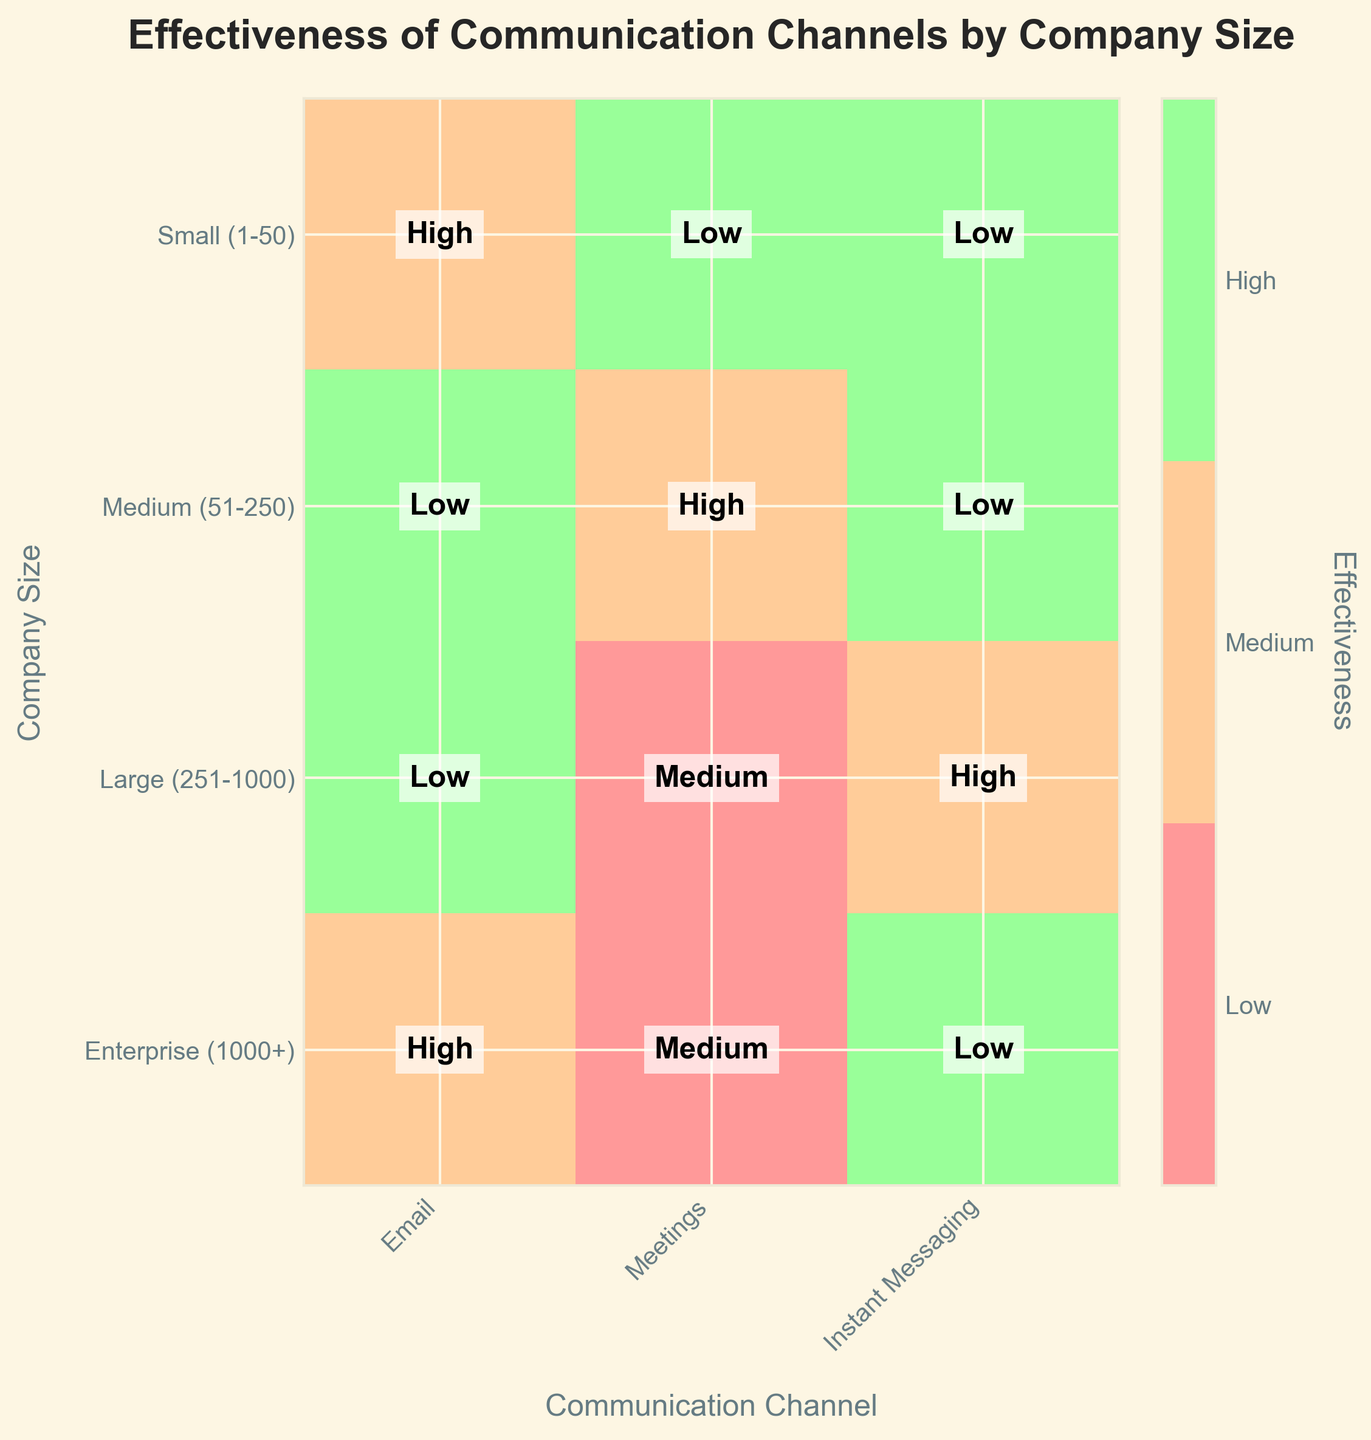Which communication channel is rated highest for small companies (1-50)? The mosaic plot shows three different channels evaluated for small companies: Email, Meetings, and Instant Messaging. By reading the respective effectiveness ratings, both Meetings and Instant Messaging are marked as 'High'. Hence, these are the highest rated channels.
Answer: Meetings and Instant Messaging What's the effectiveness rating of Meetings for Large (251-1000) companies? According to the mosaic plot, Meetings for Large companies are rated as 'Low'. This observation is made by checking the corresponding cell for Meetings and Large companies.
Answer: Low Which company size finds Instant Messaging to be of medium effectiveness? By checking the Instant Messaging column in the mosaic plot and observing the effectiveness ratings for each company size, the Large (251-1000) companies find Instant Messaging to be 'Medium' in effectiveness.
Answer: Large (251-1000) How many total 'High' effectiveness ratings are there for Email across all company sizes? We need to count the 'High' ratings in the Email row. Small (1-50) - Medium, Medium (51-250) - High, Large (251-1000) - High, and Enterprise (1000+) - Medium. Only Medium and Large companies have 'High' ratings for Email. Hence, there are 2 'High' ratings.
Answer: 2 For which company size is the effectiveness of Meetings rated the lowest? In the mosaic plot, we need to compare the effectiveness ratings of Meetings across all company sizes. The Enterprise (1000+) and Large (251-1000) companies have their Meetings rated as 'Low', but because Enterprise (1000+) generally implies being larger, it is the lowest rating for the largest group in the context of size.
Answer: Enterprise (1000+) Is there any communication channel that consistently receives a 'High' rating across all company sizes? We need to examine if any communication channel in the mosaic plot is rated as 'High' for all company sizes. Instant Messaging is rated as 'High' for Small (1-50), Medium (51-250), and Enterprise (1000+), but for Large (251-1000), it is rated as 'Medium', so no channel achieves 'High' consistently across all sizes.
Answer: No What is the most common effectiveness rating for Meetings across all company sizes? We determine the most frequent rating by counting how many times each rating (Low, Medium, High) appears in the Meetings row. Small (1-50) - High, Medium (51-250) - Medium, Large (251-1000) - Low, and Enterprise (1000+) - Low. The 'Low' rating appears more commonly (twice).
Answer: Low Compare the effectiveness of Email and Instant Messaging for Enterprise (1000+) companies. Which one is more effective? We need to compare the ratings for Email and Instant Messaging within Enterprise (1000+). Email is rated as 'Medium', while Instant Messaging is rated as 'High', indicating that Instant Messaging is more effective.
Answer: Instant Messaging What is the average effectiveness rating of communication channels for Medium (51-250) companies? To find the average effectiveness, map ratings to numbers (Low=0, Medium=1, High=2). For Medium (51-250), the ratings are Email=High(2), Meetings=Medium(1), and Instant Messaging=High(2). The average is (2+1+2)/3 = 5/3 ≈ 1.67, which falls between 'Medium' and 'High'.
Answer: Between Medium and High 